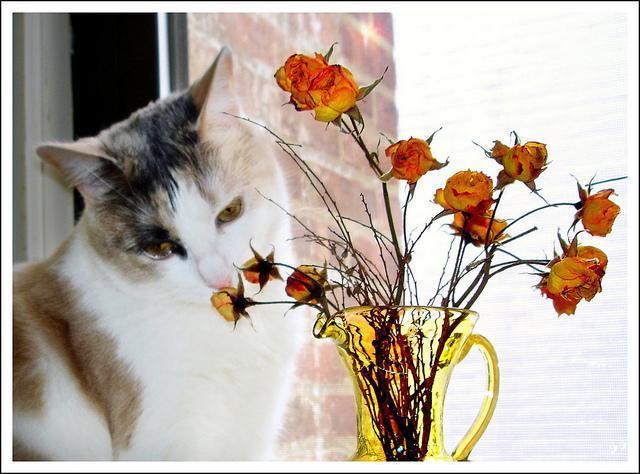How many people are wearing black pants?
Give a very brief answer. 0. 